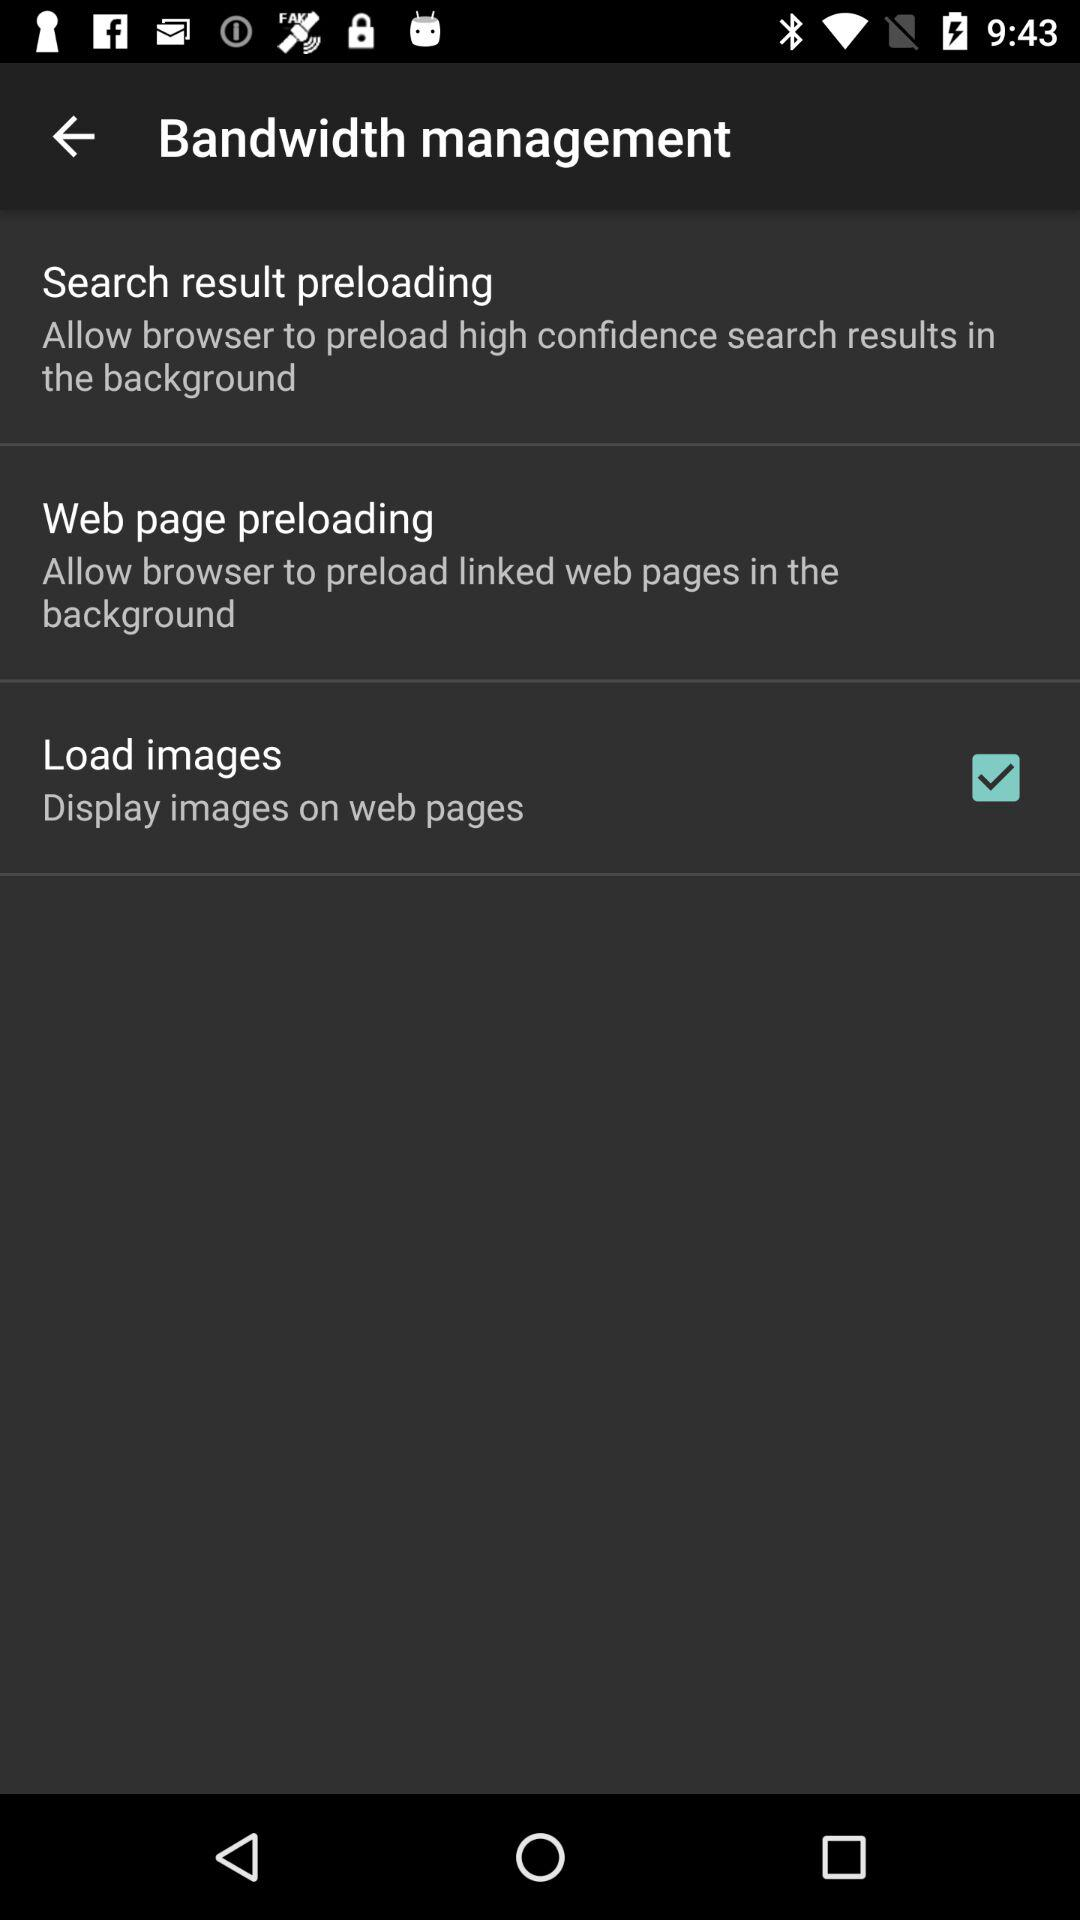Which option is checked? The checked option is "Load images". 